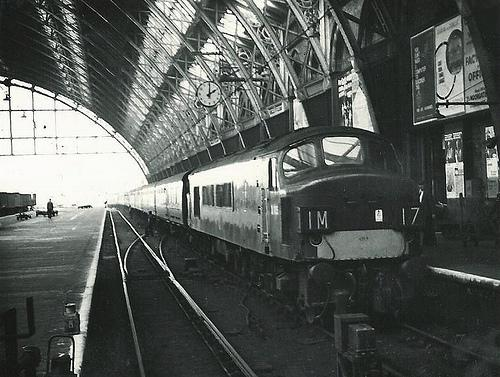Mention the top three largest objects in the image based on their size. The top three largest objects are: two sets of parallel train tracks (Width: 379, Height: 379), train in the station (Width: 377, Height: 377), and the roof of a building (Width: 337, Height: 337). Explain the state of the train tracks in the image. There are two sets of parallel train tracks, one set without a train, and another set with tracks merging into one. Analyze and describe any reflection you observe in the image. There is a reflection in the window (Width: 48, Height: 48) which could possibly be the surrounding scenery or objects near the train. Provide a brief description of the main objects in the image. There are several cats under colorful umbrellas, a train on tracks, a person standing on concrete and walking on the ground, walls on the sides of buildings, and windows of the train. Identify and count the number of total cat images in the given metadata. There are a total of 9 cat images. Describe any visible interaction between objects in the image. There's no clear interaction between objects in the image, but one could interpret the cats and umbrellas as interacting, and the train tracks merging as another interaction. Rate the image quality based on the given metadata (poor, average, good, excellent). Since we cannot see the actual image, it is not possible to rate the image quality based on the given metadata alone. What is the general atmosphere or sentiment evoked by the image? The image evokes a busy and lively atmosphere with various objects and elements, mainly focusing on the train and its surroundings. What are the prominent features of the train in this image? The prominent features of the train include windows, numbers on the front, light shining on the side, wheels, bumper, and letters. What is the main mode of transportation in the image? The main mode of transportation in the image is a train. Describe the sentiment of the image based on the objects present. Neutral to positive, a peaceful scene with a cat and train. Notice the group of birds flying above the train. No, it's not mentioned in the image. How many sets of train tracks are present in the image? 2 Identify the attributes of the train in the image. Windows, numbers, light shining, reflection, front, wheels, bumper, letters. List the objects found in the image. Cat, umbrella, train, tracks, windows, person, building, roof, wall. Describe the interaction between the cat and umbrella. The cat is up under a colorful umbrella. Specify the location and dimensions of the roof of a building. X:27 Y:13 Width:337 Height:337 Do the two sets of tracks merge at some point in the image? Yes, X:123 Y:223 Width:57 Height:57 Locate the windows on the front of the train. X:276 Y:137 Width:128 Height:128 What are the coordinates and dimensions of the person standing on concrete? X:42 Y:195 Width:15 Height:15 Count the number of captions mentioning "cat up under a colorful umbrella." 9 Assess the image quality based on the information provided. Cannot accurately assess without viewing the actual image. Identify the text and numbers present on the train. Numbers: 397, 203, 25, 25. Identify objects in the image with a width greater than 300. Train on the tracks, two sets of parallel train tracks, train in the station, roof of a building. Is the train arriving at or leaving the station? Cannot determine without viewing the actual image. Describe the location of the train. On the tracks, X:85 Y:118 Width:377 Height:377 Detect the labels that are associated with the train. Train on the tracks, windows on the front, numbers on the front, light shining on the side, reflection in the window, front of a train, wheels, bumper, letters. 